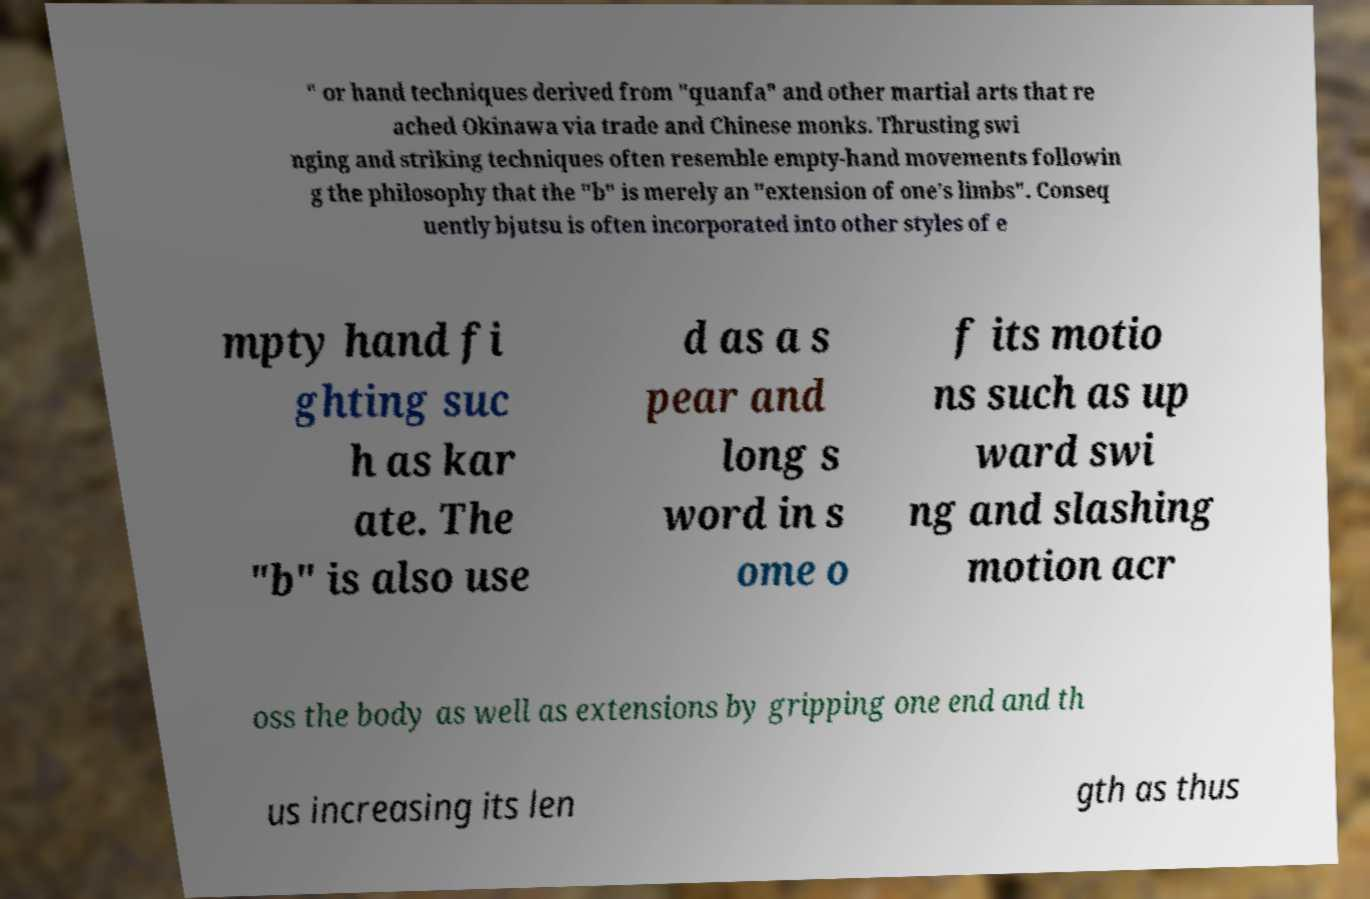Can you accurately transcribe the text from the provided image for me? " or hand techniques derived from "quanfa" and other martial arts that re ached Okinawa via trade and Chinese monks. Thrusting swi nging and striking techniques often resemble empty-hand movements followin g the philosophy that the "b" is merely an "extension of one’s limbs". Conseq uently bjutsu is often incorporated into other styles of e mpty hand fi ghting suc h as kar ate. The "b" is also use d as a s pear and long s word in s ome o f its motio ns such as up ward swi ng and slashing motion acr oss the body as well as extensions by gripping one end and th us increasing its len gth as thus 